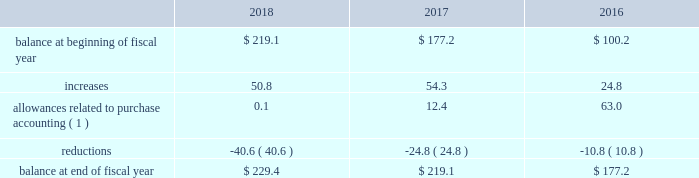Westrock company notes to consolidated financial statements fffd ( continued ) at september 30 , 2018 and september 30 , 2017 , gross net operating losses for foreign reporting purposes of approximately $ 698.4 million and $ 673.7 million , respectively , were available for carryforward .
A majority of these loss carryforwards generally expire between fiscal 2020 and 2038 , while a portion have an indefinite carryforward .
The tax effected values of these net operating losses are $ 185.8 million and $ 182.6 million at september 30 , 2018 and 2017 , respectively , exclusive of valuation allowances of $ 161.5 million and $ 149.6 million at september 30 , 2018 and 2017 , respectively .
At september 30 , 2018 and 2017 , we had state tax credit carryforwards of $ 64.8 million and $ 54.4 million , respectively .
These state tax credit carryforwards generally expire within 5 to 10 years ; however , certain state credits can be carried forward indefinitely .
Valuation allowances of $ 56.1 million and $ 47.3 million at september 30 , 2018 and 2017 , respectively , have been provided on these assets .
These valuation allowances have been recorded due to uncertainty regarding our ability to generate sufficient taxable income in the appropriate taxing jurisdiction .
The table represents a summary of the valuation allowances against deferred tax assets for fiscal 2018 , 2017 and 2016 ( in millions ) : .
( 1 ) amounts in fiscal 2018 and 2017 relate to the mps acquisition .
Adjustments in fiscal 2016 relate to the combination and the sp fiber acquisition .
Consistent with prior years , we consider a portion of our earnings from certain foreign subsidiaries as subject to repatriation and we provide for taxes accordingly .
However , we consider the unremitted earnings and all other outside basis differences from all other foreign subsidiaries to be indefinitely reinvested .
Accordingly , we have not provided for any taxes that would be due .
As of september 30 , 2018 , we estimate our outside basis difference in foreign subsidiaries that are considered indefinitely reinvested to be approximately $ 1.5 billion .
The components of the outside basis difference are comprised of purchase accounting adjustments , undistributed earnings , and equity components .
Except for the portion of our earnings from certain foreign subsidiaries where we provided for taxes , we have not provided for any taxes that would be due upon the reversal of the outside basis differences .
However , in the event of a distribution in the form of dividends or dispositions of the subsidiaries , we may be subject to incremental u.s .
Income taxes , subject to an adjustment for foreign tax credits , and withholding taxes or income taxes payable to the foreign jurisdictions .
As of september 30 , 2018 , the determination of the amount of unrecognized deferred tax liability related to any remaining undistributed foreign earnings not subject to the transition tax and additional outside basis differences is not practicable. .
How much has the balance increased in a percentage from 2016 to 2018? 
Rationale: to find the percentage increase you must first subtract 2018 by 2016 and then take that answer and divide by 2016 .
Computations: ((229.4 - 177.2) / 177.2)
Answer: 0.29458. 